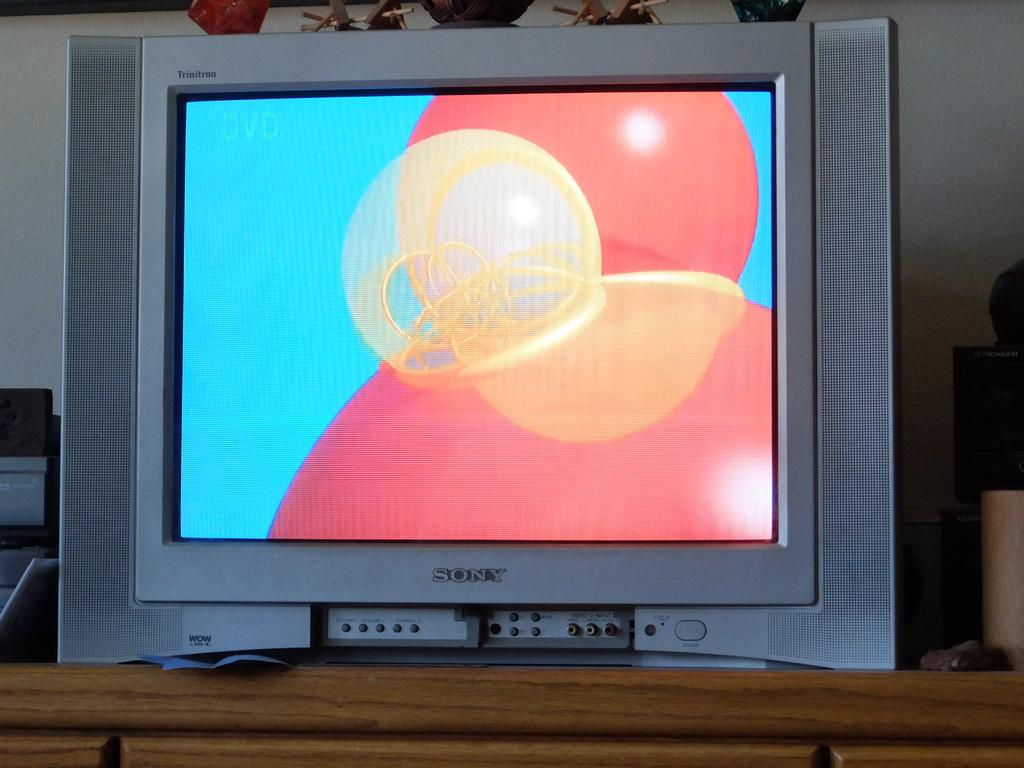<image>
Provide a brief description of the given image. A Sony TV screen that is turned on. 